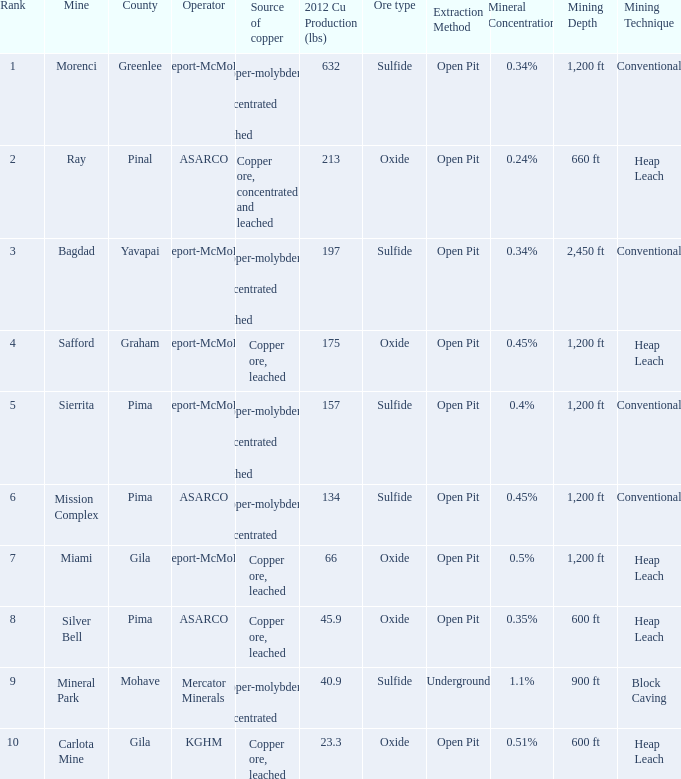What's the name of the operator who has the mission complex mine and has a 2012 Cu Production (lbs) larger than 23.3? ASARCO. 